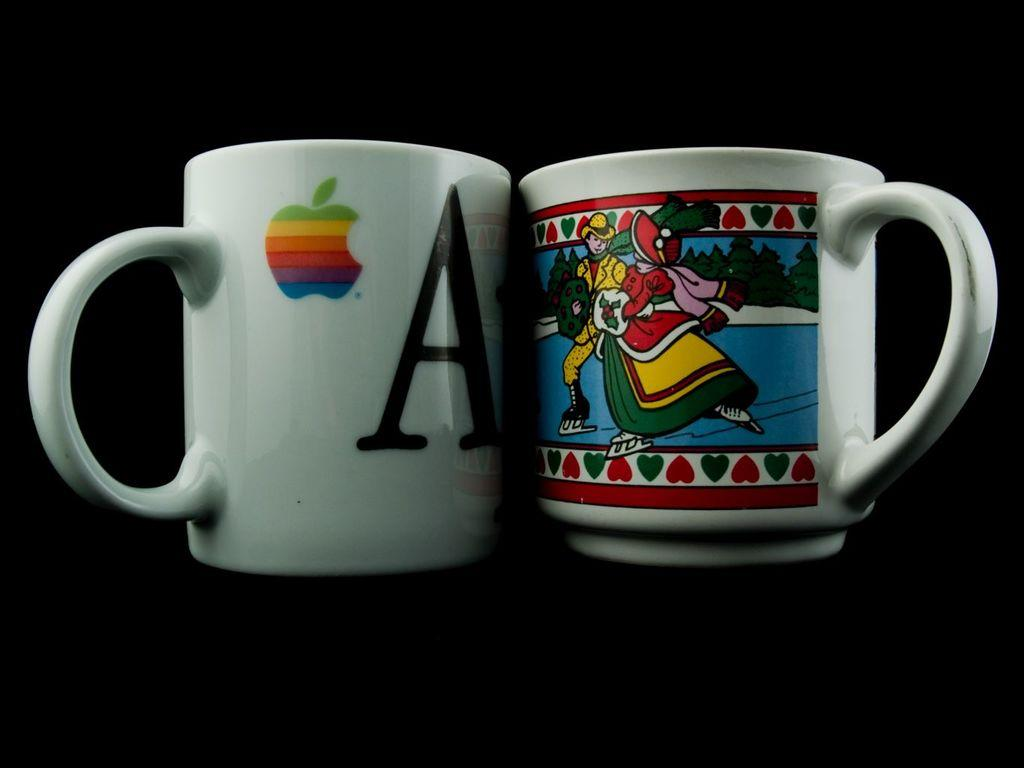<image>
Offer a succinct explanation of the picture presented. Two coffee mugs with the mac brand and a Letter a printed in bold on the left. 